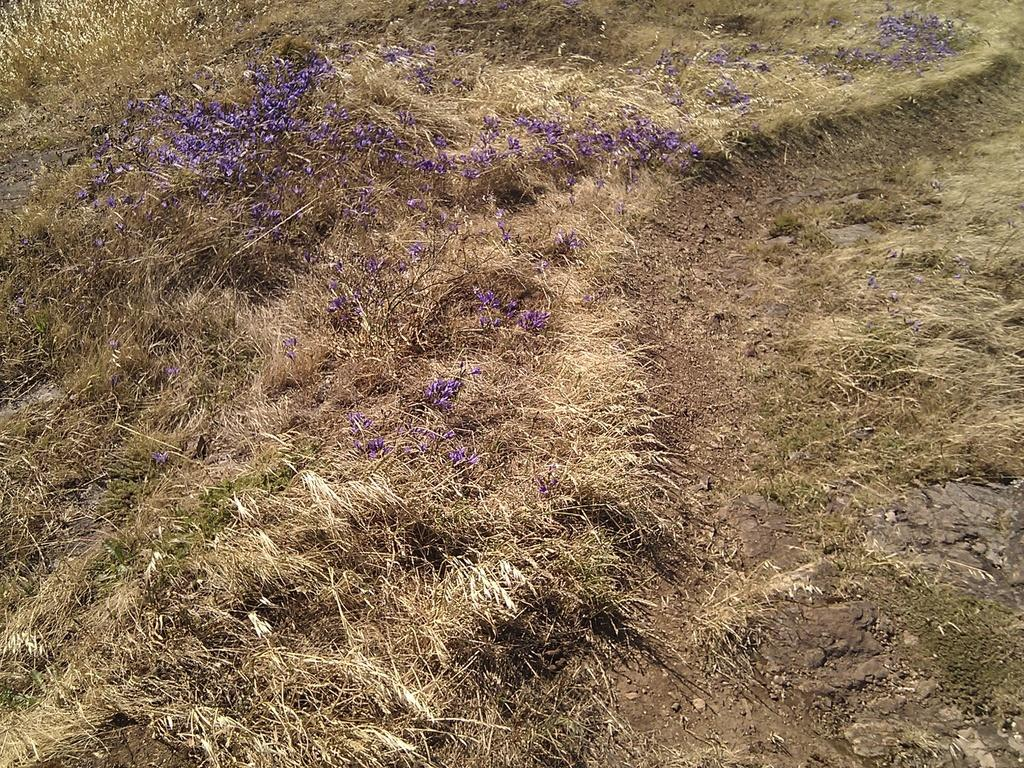What type of plants can be seen in the image? There are lavender flower plants in the image. What is the condition of the ground where the plants are located? The plants are on dry grassland. Can you see any hospitals in the image? There are no hospitals visible in the image; it features lavender plants on dry grassland. 